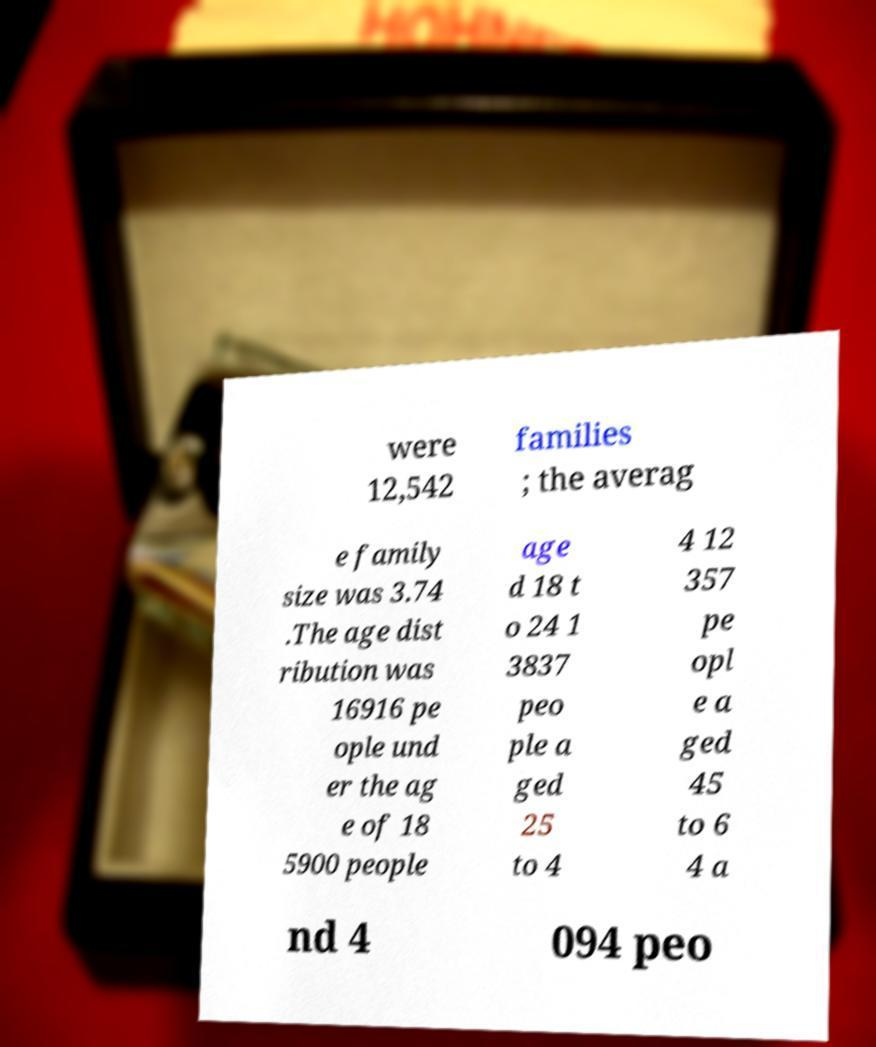There's text embedded in this image that I need extracted. Can you transcribe it verbatim? were 12,542 families ; the averag e family size was 3.74 .The age dist ribution was 16916 pe ople und er the ag e of 18 5900 people age d 18 t o 24 1 3837 peo ple a ged 25 to 4 4 12 357 pe opl e a ged 45 to 6 4 a nd 4 094 peo 